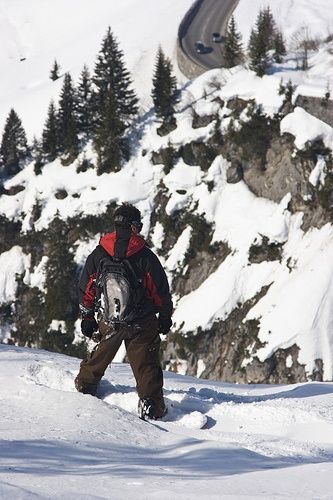Describe the objects in this image and their specific colors. I can see people in white, black, maroon, gray, and darkgray tones, backpack in white, black, gray, and darkgray tones, snowboard in white, lightgray, gray, and darkgray tones, car in white, black, and gray tones, and car in white, gray, black, and blue tones in this image. 